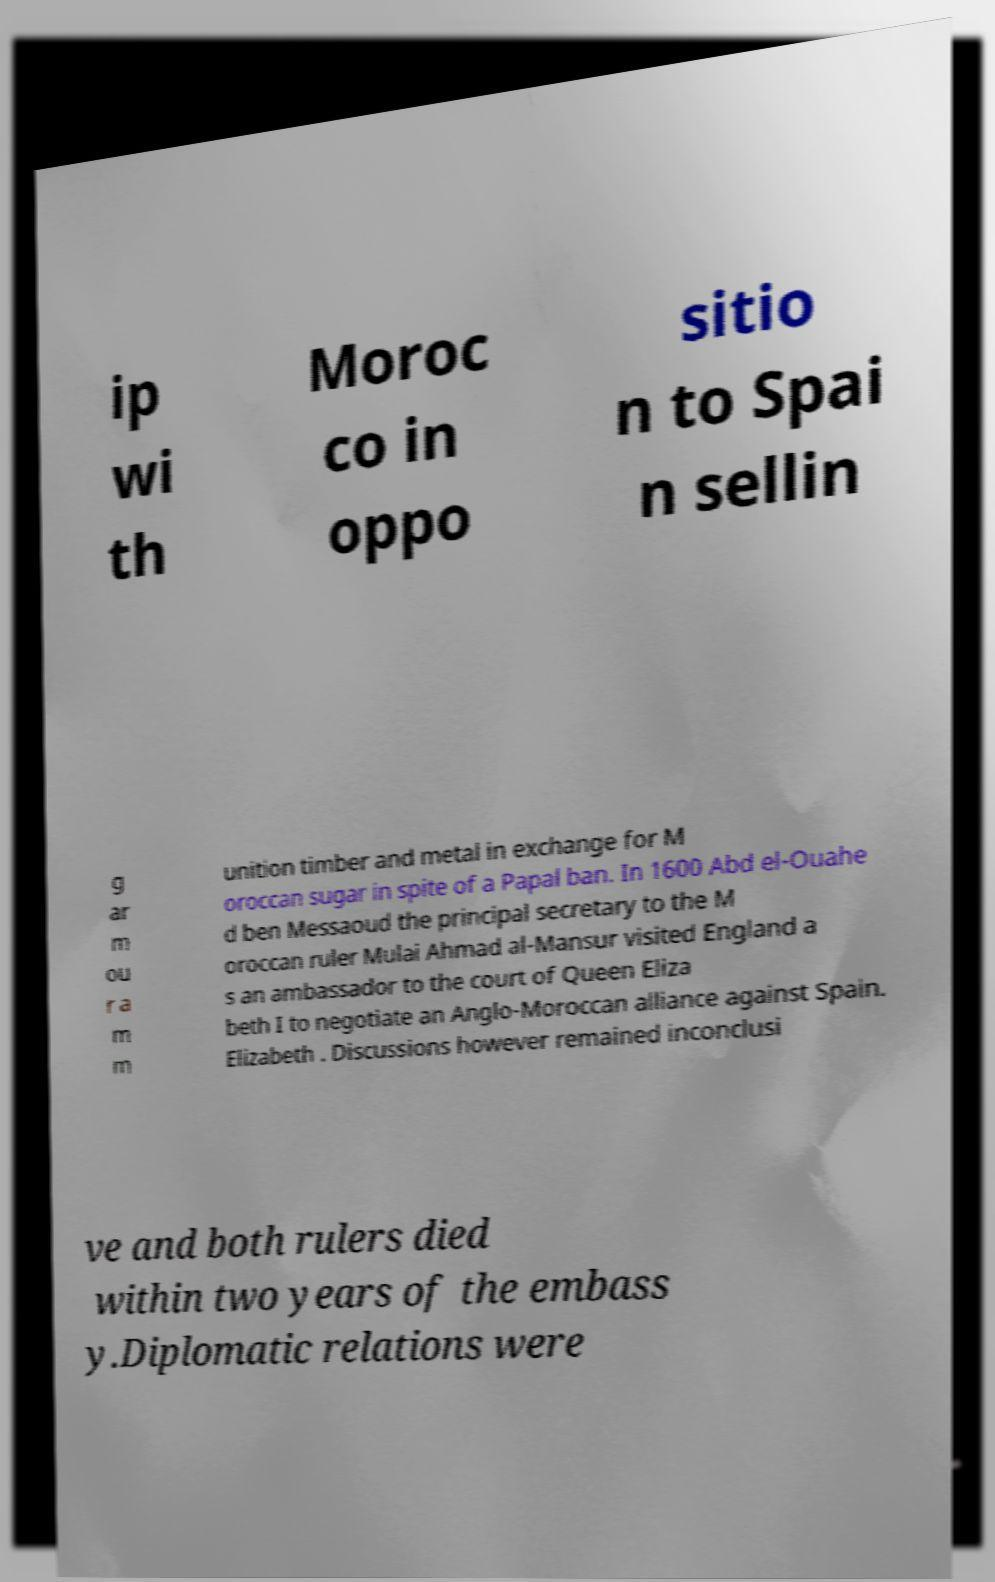Can you accurately transcribe the text from the provided image for me? ip wi th Moroc co in oppo sitio n to Spai n sellin g ar m ou r a m m unition timber and metal in exchange for M oroccan sugar in spite of a Papal ban. In 1600 Abd el-Ouahe d ben Messaoud the principal secretary to the M oroccan ruler Mulai Ahmad al-Mansur visited England a s an ambassador to the court of Queen Eliza beth I to negotiate an Anglo-Moroccan alliance against Spain. Elizabeth . Discussions however remained inconclusi ve and both rulers died within two years of the embass y.Diplomatic relations were 